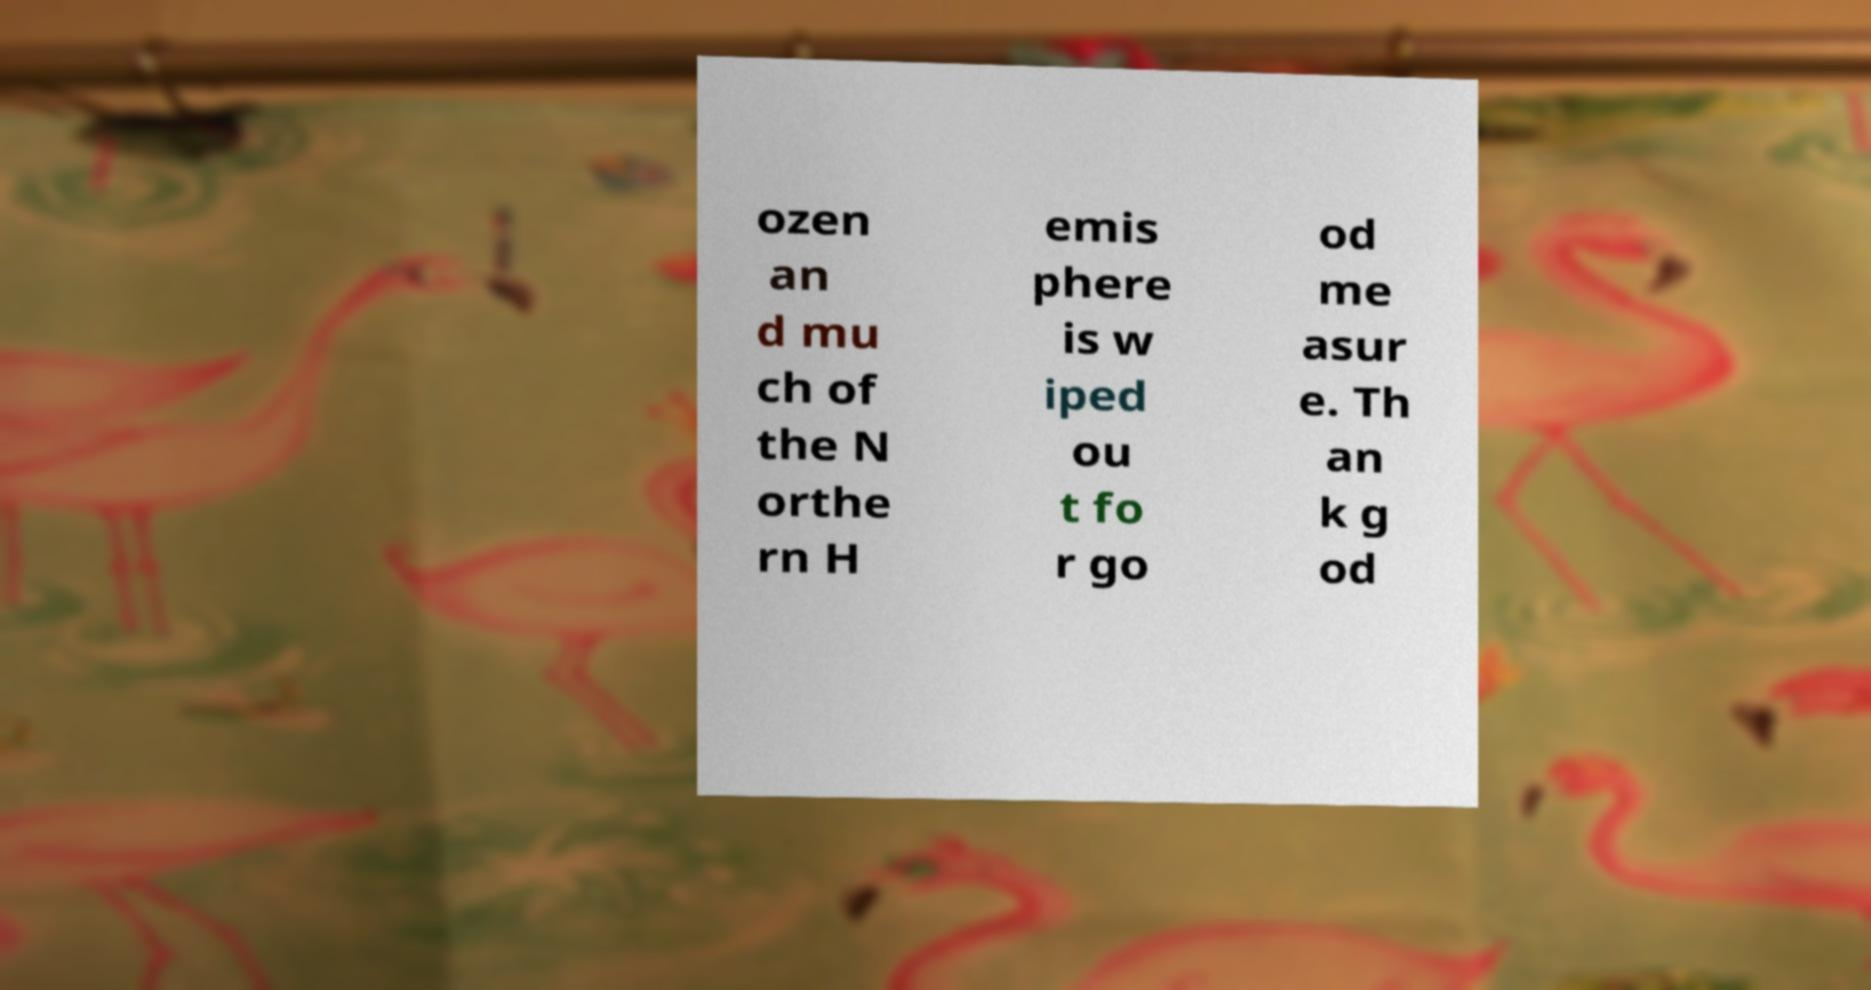Could you extract and type out the text from this image? ozen an d mu ch of the N orthe rn H emis phere is w iped ou t fo r go od me asur e. Th an k g od 